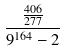Convert formula to latex. <formula><loc_0><loc_0><loc_500><loc_500>\frac { \frac { 4 0 6 } { 2 7 7 } } { 9 ^ { 1 6 4 } - 2 }</formula> 